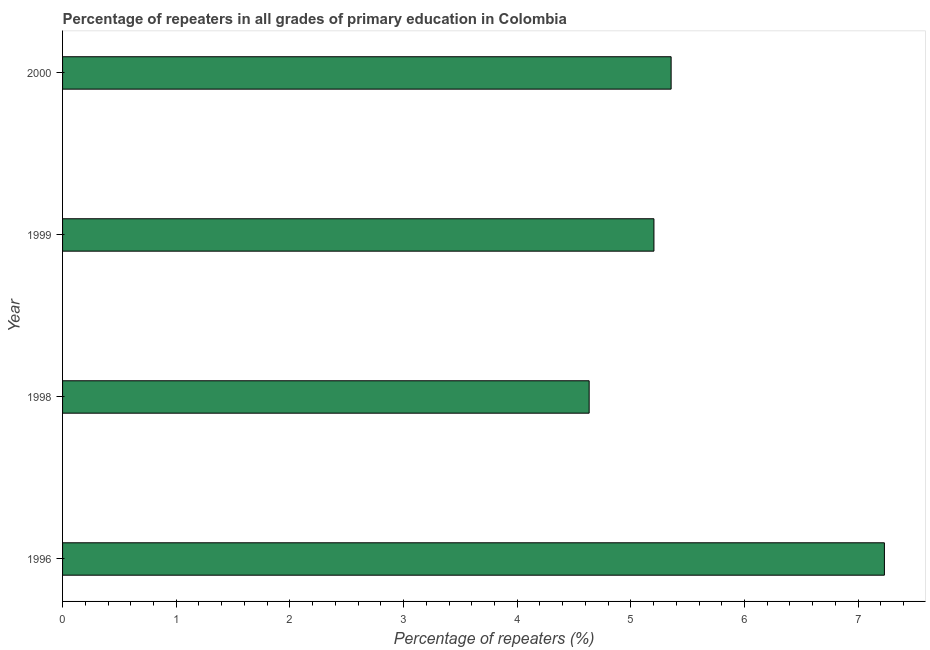Does the graph contain any zero values?
Your answer should be very brief. No. Does the graph contain grids?
Give a very brief answer. No. What is the title of the graph?
Offer a very short reply. Percentage of repeaters in all grades of primary education in Colombia. What is the label or title of the X-axis?
Provide a succinct answer. Percentage of repeaters (%). What is the label or title of the Y-axis?
Provide a short and direct response. Year. What is the percentage of repeaters in primary education in 1999?
Give a very brief answer. 5.2. Across all years, what is the maximum percentage of repeaters in primary education?
Your answer should be compact. 7.23. Across all years, what is the minimum percentage of repeaters in primary education?
Give a very brief answer. 4.63. In which year was the percentage of repeaters in primary education minimum?
Give a very brief answer. 1998. What is the sum of the percentage of repeaters in primary education?
Ensure brevity in your answer.  22.42. What is the difference between the percentage of repeaters in primary education in 1996 and 1999?
Provide a short and direct response. 2.03. What is the average percentage of repeaters in primary education per year?
Keep it short and to the point. 5.61. What is the median percentage of repeaters in primary education?
Ensure brevity in your answer.  5.28. What is the ratio of the percentage of repeaters in primary education in 1998 to that in 1999?
Your answer should be very brief. 0.89. Is the percentage of repeaters in primary education in 1998 less than that in 1999?
Offer a very short reply. Yes. Is the difference between the percentage of repeaters in primary education in 1998 and 1999 greater than the difference between any two years?
Offer a very short reply. No. What is the difference between the highest and the second highest percentage of repeaters in primary education?
Offer a terse response. 1.88. Is the sum of the percentage of repeaters in primary education in 1998 and 2000 greater than the maximum percentage of repeaters in primary education across all years?
Provide a succinct answer. Yes. In how many years, is the percentage of repeaters in primary education greater than the average percentage of repeaters in primary education taken over all years?
Your answer should be compact. 1. How many bars are there?
Offer a terse response. 4. Are the values on the major ticks of X-axis written in scientific E-notation?
Offer a terse response. No. What is the Percentage of repeaters (%) of 1996?
Your response must be concise. 7.23. What is the Percentage of repeaters (%) in 1998?
Ensure brevity in your answer.  4.63. What is the Percentage of repeaters (%) in 1999?
Ensure brevity in your answer.  5.2. What is the Percentage of repeaters (%) of 2000?
Offer a terse response. 5.35. What is the difference between the Percentage of repeaters (%) in 1996 and 1998?
Your response must be concise. 2.6. What is the difference between the Percentage of repeaters (%) in 1996 and 1999?
Keep it short and to the point. 2.03. What is the difference between the Percentage of repeaters (%) in 1996 and 2000?
Offer a very short reply. 1.88. What is the difference between the Percentage of repeaters (%) in 1998 and 1999?
Ensure brevity in your answer.  -0.57. What is the difference between the Percentage of repeaters (%) in 1998 and 2000?
Offer a very short reply. -0.72. What is the difference between the Percentage of repeaters (%) in 1999 and 2000?
Provide a succinct answer. -0.15. What is the ratio of the Percentage of repeaters (%) in 1996 to that in 1998?
Give a very brief answer. 1.56. What is the ratio of the Percentage of repeaters (%) in 1996 to that in 1999?
Give a very brief answer. 1.39. What is the ratio of the Percentage of repeaters (%) in 1996 to that in 2000?
Your response must be concise. 1.35. What is the ratio of the Percentage of repeaters (%) in 1998 to that in 1999?
Provide a short and direct response. 0.89. What is the ratio of the Percentage of repeaters (%) in 1998 to that in 2000?
Give a very brief answer. 0.86. What is the ratio of the Percentage of repeaters (%) in 1999 to that in 2000?
Keep it short and to the point. 0.97. 